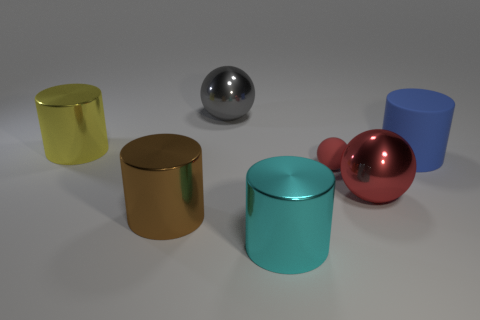What number of gray metal things are on the right side of the metal ball right of the large cylinder in front of the brown metal cylinder?
Your response must be concise. 0. The ball that is left of the large cyan thing is what color?
Give a very brief answer. Gray. What is the material of the big thing that is in front of the large yellow metal thing and left of the cyan shiny cylinder?
Your answer should be compact. Metal. What number of gray metal balls are on the right side of the metallic sphere behind the red shiny thing?
Provide a short and direct response. 0. There is a big yellow object; what shape is it?
Your answer should be very brief. Cylinder. What is the shape of the object that is made of the same material as the small ball?
Offer a very short reply. Cylinder. Is the shape of the matte thing that is on the left side of the blue cylinder the same as  the large cyan metallic thing?
Your response must be concise. No. What shape is the rubber object left of the rubber cylinder?
Provide a succinct answer. Sphere. The big thing that is the same color as the tiny matte ball is what shape?
Make the answer very short. Sphere. What number of cyan objects have the same size as the gray shiny sphere?
Your response must be concise. 1. 